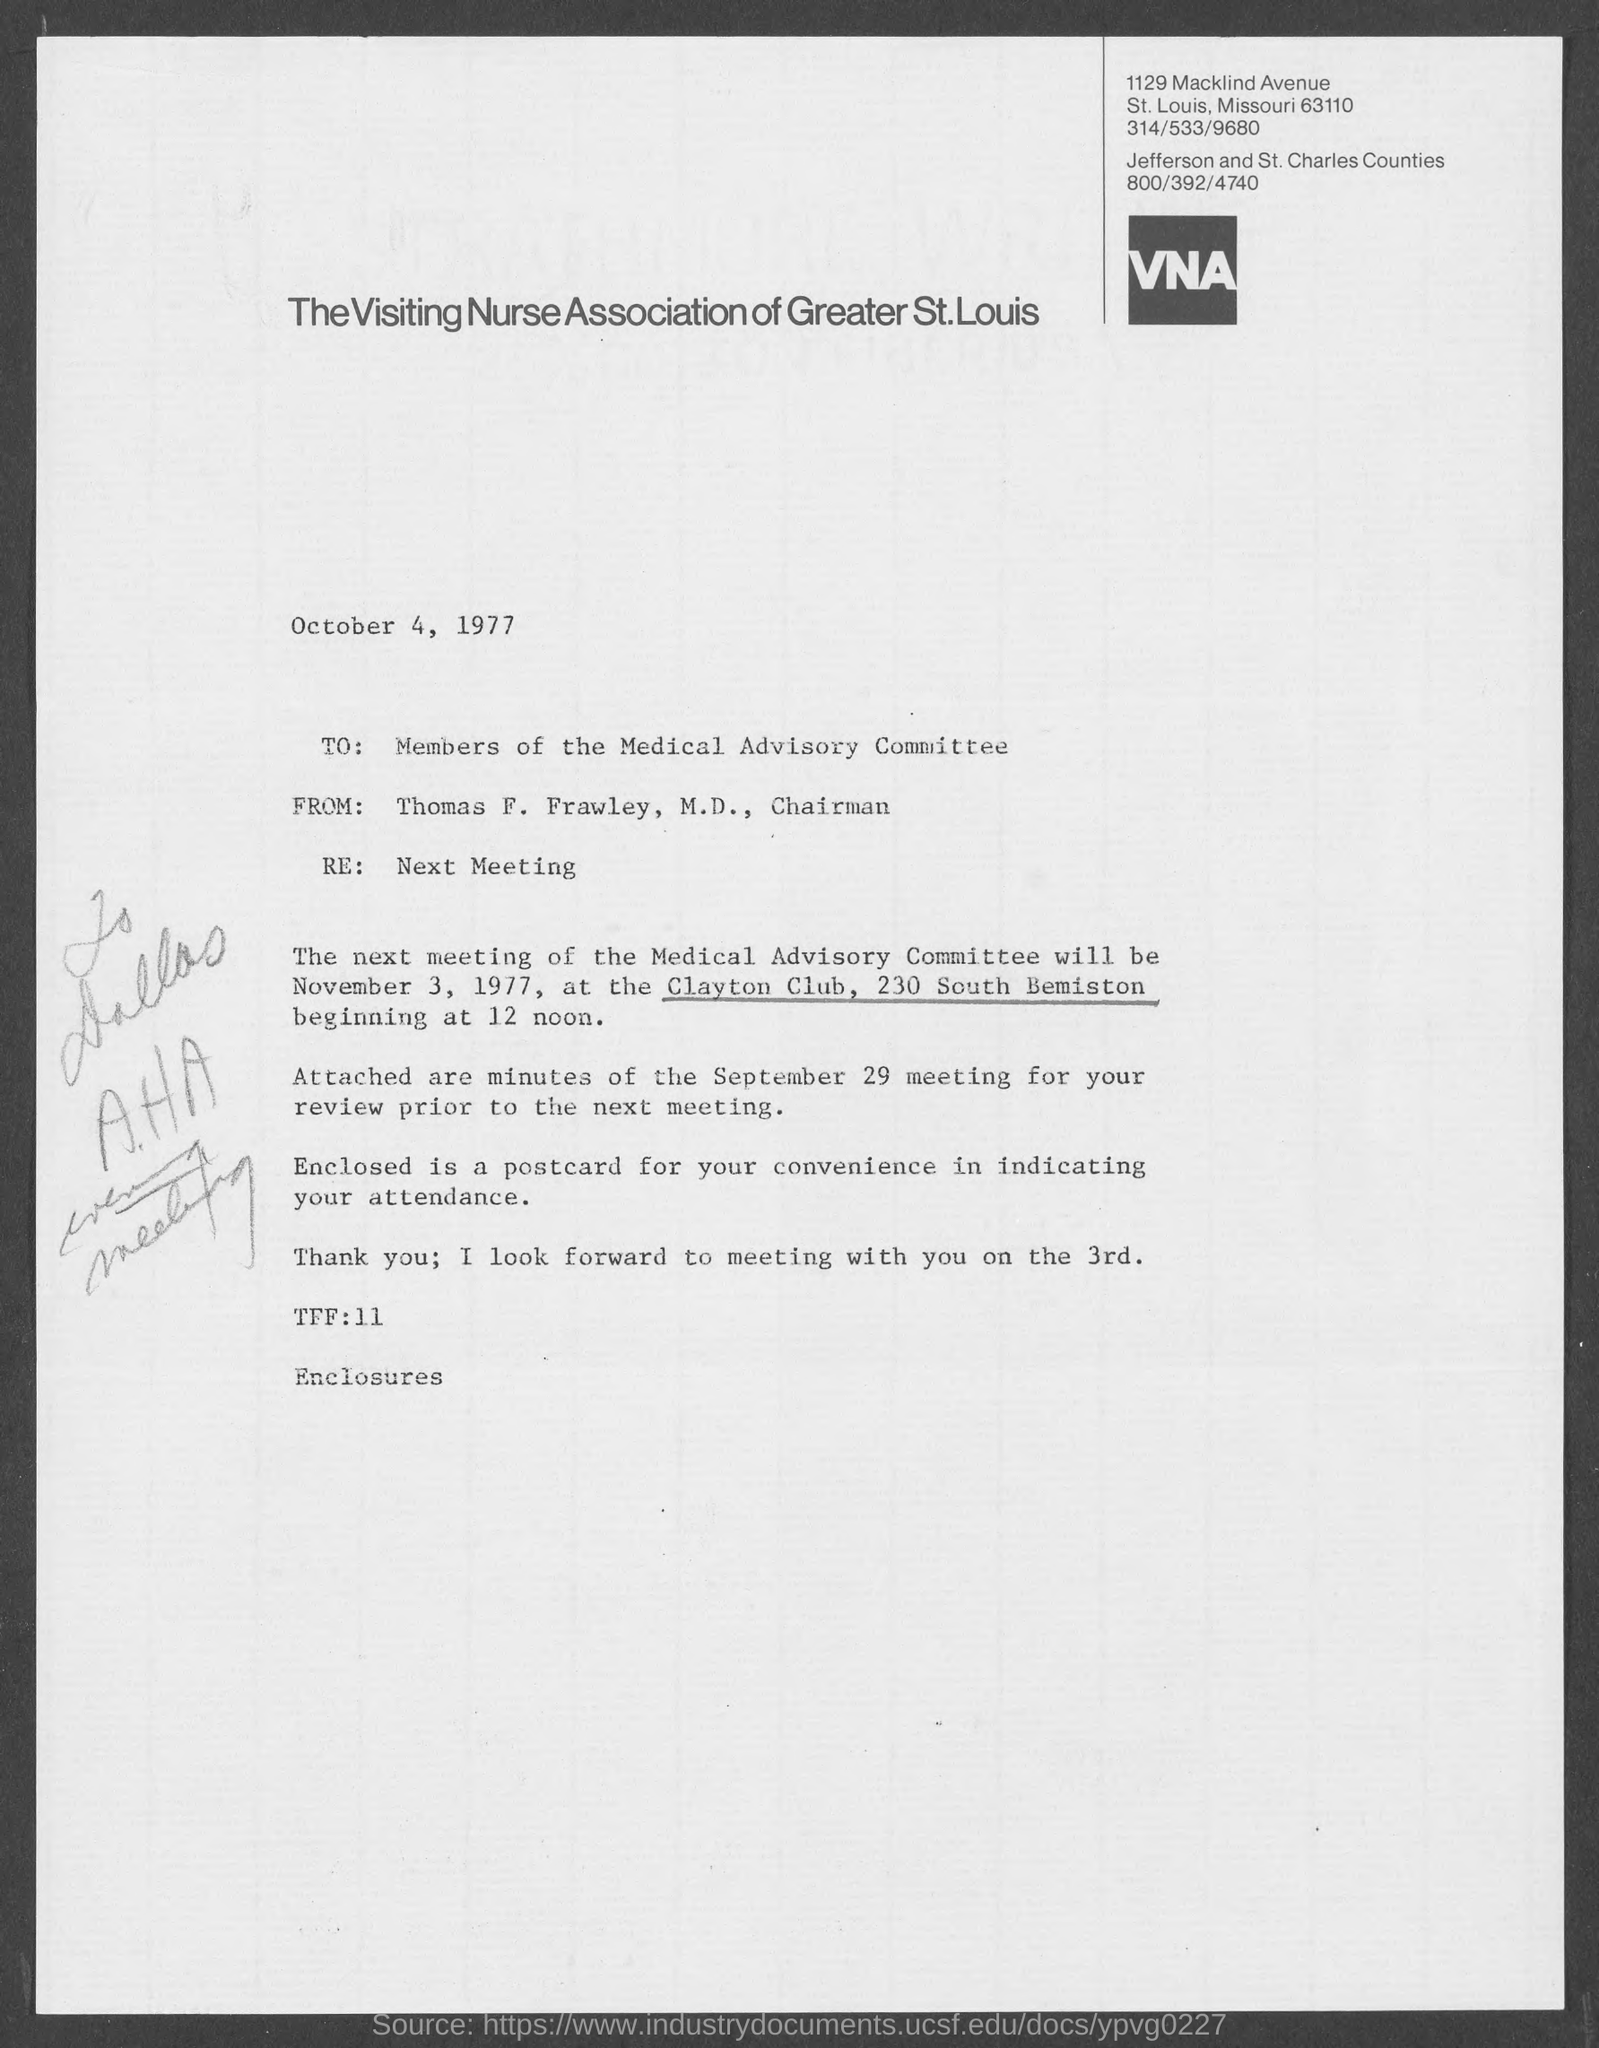Who wrote this letter?
Your answer should be very brief. Thomas f. frawley, m.d. To whom this letter is written to?
Your answer should be very brief. Members of the Medical Advisory Committee. Where would the next meeting of medical advisory committee will be held at ?
Make the answer very short. Clayton Club, 230 South Bemiston. On what date would the next meeting of Medical Advisory Committee will be held on?
Make the answer very short. November 3, 1977. What is the date of intimation?
Provide a short and direct response. October 4, 1977. 